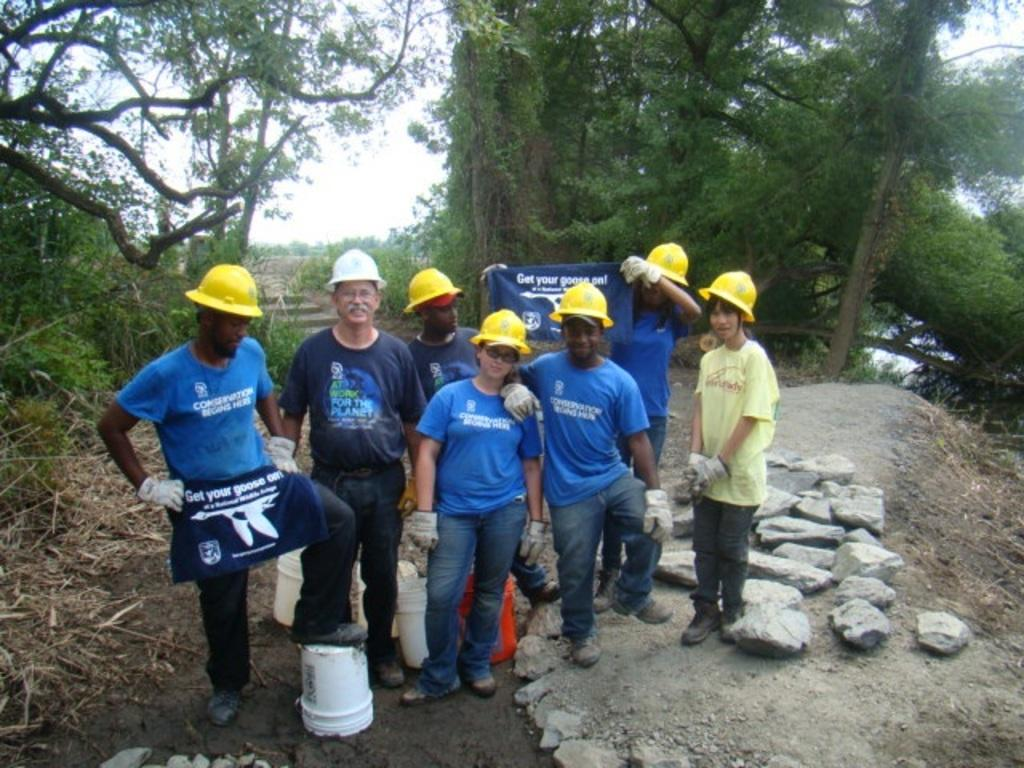<image>
Describe the image concisely. People with construction helmets and blue shirts and a blue apron that has Get your goose on in white letters. 